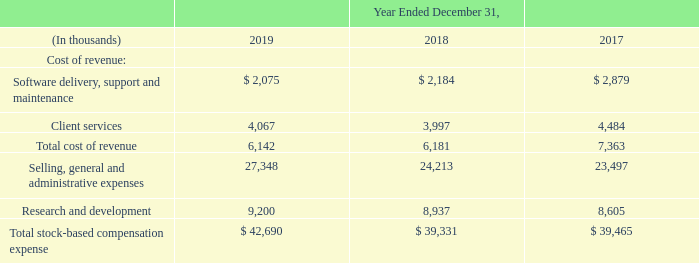11. Stock Award Plan
Total recognized stock-based compensation expense is included in our consolidated statements of operations as shown in the table below. Stock-based compensation expense includes both non-cash expense related to grants of stock-based awards as well as cash expense related to the employee discount applied to purchases of our common stock under our employee stock purchase plan.
The estimated income tax benefit of stock-based compensation expense included in the provision for income taxes for the year ended December 31, 2019 is approximately $5.3 million. No stock-based compensation costs were capitalized during the years ended December 31, 2019, 2018 and 2017. The calculation of stock-based compensation expenses includes an estimate for forfeitures at the time of grant.
This estimate can be revised in subsequent periods if actual forfeitures differ from those estimates, which are based on historical trends. Total unrecognized stock-based compensation expense related to nonvested awards and options was $62.4 million as of December 31, 2019, and this expense is expected to be recognized over a weighted-average period of 2.3 years.
What is included in the stock-based compensation? Includes both non-cash expense related to grants of stock-based awards as well as cash expense related to the employee discount applied to purchases of our common stock under our employee stock purchase plan. What was the estimated income tax benefit of stock based compensation expense included in the provision for income taxes in 2019? $5.3 million. What was the total unrecognized stock-based compensation expense in 2019? $62.4 million. What was the change in the Software delivery, support and maintenance value from 2018 to 2019?
Answer scale should be: thousand. 2,075 - 2,184
Answer: -109. What is the average Client services for 2017-2019?
Answer scale should be: thousand. (4,067 + 3,997 + 4,484) / 3
Answer: 4182.67. What is the change in the Total cost of revenue from 2018 to 2019?
Answer scale should be: thousand. 6,142 - 6,181
Answer: -39. 